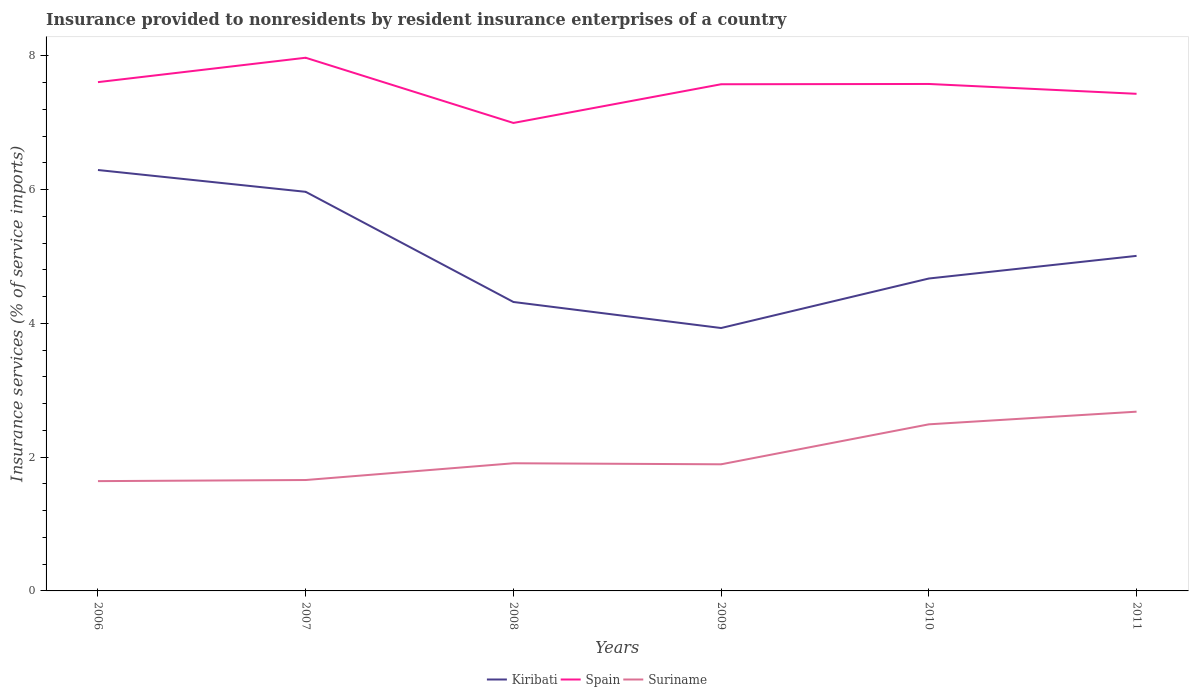Across all years, what is the maximum insurance provided to nonresidents in Spain?
Your response must be concise. 7. In which year was the insurance provided to nonresidents in Kiribati maximum?
Provide a succinct answer. 2009. What is the total insurance provided to nonresidents in Suriname in the graph?
Give a very brief answer. -0.23. What is the difference between the highest and the second highest insurance provided to nonresidents in Kiribati?
Provide a succinct answer. 2.36. What is the difference between the highest and the lowest insurance provided to nonresidents in Kiribati?
Your response must be concise. 2. Is the insurance provided to nonresidents in Kiribati strictly greater than the insurance provided to nonresidents in Spain over the years?
Make the answer very short. Yes. How many lines are there?
Offer a very short reply. 3. What is the difference between two consecutive major ticks on the Y-axis?
Make the answer very short. 2. Does the graph contain any zero values?
Ensure brevity in your answer.  No. Does the graph contain grids?
Provide a short and direct response. No. How are the legend labels stacked?
Give a very brief answer. Horizontal. What is the title of the graph?
Your response must be concise. Insurance provided to nonresidents by resident insurance enterprises of a country. What is the label or title of the Y-axis?
Make the answer very short. Insurance services (% of service imports). What is the Insurance services (% of service imports) of Kiribati in 2006?
Give a very brief answer. 6.29. What is the Insurance services (% of service imports) in Spain in 2006?
Make the answer very short. 7.61. What is the Insurance services (% of service imports) of Suriname in 2006?
Give a very brief answer. 1.64. What is the Insurance services (% of service imports) in Kiribati in 2007?
Give a very brief answer. 5.97. What is the Insurance services (% of service imports) in Spain in 2007?
Provide a succinct answer. 7.97. What is the Insurance services (% of service imports) of Suriname in 2007?
Ensure brevity in your answer.  1.66. What is the Insurance services (% of service imports) in Kiribati in 2008?
Make the answer very short. 4.32. What is the Insurance services (% of service imports) of Spain in 2008?
Provide a short and direct response. 7. What is the Insurance services (% of service imports) of Suriname in 2008?
Keep it short and to the point. 1.91. What is the Insurance services (% of service imports) of Kiribati in 2009?
Your answer should be very brief. 3.93. What is the Insurance services (% of service imports) of Spain in 2009?
Your answer should be very brief. 7.57. What is the Insurance services (% of service imports) in Suriname in 2009?
Your answer should be very brief. 1.89. What is the Insurance services (% of service imports) in Kiribati in 2010?
Offer a very short reply. 4.67. What is the Insurance services (% of service imports) in Spain in 2010?
Your answer should be compact. 7.58. What is the Insurance services (% of service imports) in Suriname in 2010?
Keep it short and to the point. 2.49. What is the Insurance services (% of service imports) of Kiribati in 2011?
Offer a very short reply. 5.01. What is the Insurance services (% of service imports) of Spain in 2011?
Make the answer very short. 7.43. What is the Insurance services (% of service imports) in Suriname in 2011?
Provide a succinct answer. 2.68. Across all years, what is the maximum Insurance services (% of service imports) of Kiribati?
Keep it short and to the point. 6.29. Across all years, what is the maximum Insurance services (% of service imports) in Spain?
Provide a short and direct response. 7.97. Across all years, what is the maximum Insurance services (% of service imports) of Suriname?
Your response must be concise. 2.68. Across all years, what is the minimum Insurance services (% of service imports) in Kiribati?
Provide a short and direct response. 3.93. Across all years, what is the minimum Insurance services (% of service imports) of Spain?
Your answer should be very brief. 7. Across all years, what is the minimum Insurance services (% of service imports) in Suriname?
Offer a terse response. 1.64. What is the total Insurance services (% of service imports) of Kiribati in the graph?
Provide a succinct answer. 30.19. What is the total Insurance services (% of service imports) of Spain in the graph?
Your answer should be very brief. 45.15. What is the total Insurance services (% of service imports) of Suriname in the graph?
Your answer should be compact. 12.27. What is the difference between the Insurance services (% of service imports) in Kiribati in 2006 and that in 2007?
Provide a short and direct response. 0.33. What is the difference between the Insurance services (% of service imports) in Spain in 2006 and that in 2007?
Provide a short and direct response. -0.36. What is the difference between the Insurance services (% of service imports) of Suriname in 2006 and that in 2007?
Your answer should be very brief. -0.02. What is the difference between the Insurance services (% of service imports) of Kiribati in 2006 and that in 2008?
Your answer should be very brief. 1.97. What is the difference between the Insurance services (% of service imports) of Spain in 2006 and that in 2008?
Offer a very short reply. 0.61. What is the difference between the Insurance services (% of service imports) in Suriname in 2006 and that in 2008?
Keep it short and to the point. -0.27. What is the difference between the Insurance services (% of service imports) of Kiribati in 2006 and that in 2009?
Offer a very short reply. 2.36. What is the difference between the Insurance services (% of service imports) in Spain in 2006 and that in 2009?
Keep it short and to the point. 0.03. What is the difference between the Insurance services (% of service imports) of Suriname in 2006 and that in 2009?
Make the answer very short. -0.25. What is the difference between the Insurance services (% of service imports) in Kiribati in 2006 and that in 2010?
Offer a terse response. 1.62. What is the difference between the Insurance services (% of service imports) of Spain in 2006 and that in 2010?
Offer a very short reply. 0.03. What is the difference between the Insurance services (% of service imports) of Suriname in 2006 and that in 2010?
Make the answer very short. -0.85. What is the difference between the Insurance services (% of service imports) in Kiribati in 2006 and that in 2011?
Your answer should be very brief. 1.28. What is the difference between the Insurance services (% of service imports) in Spain in 2006 and that in 2011?
Offer a terse response. 0.17. What is the difference between the Insurance services (% of service imports) in Suriname in 2006 and that in 2011?
Offer a very short reply. -1.04. What is the difference between the Insurance services (% of service imports) of Kiribati in 2007 and that in 2008?
Make the answer very short. 1.65. What is the difference between the Insurance services (% of service imports) of Spain in 2007 and that in 2008?
Make the answer very short. 0.97. What is the difference between the Insurance services (% of service imports) in Suriname in 2007 and that in 2008?
Your response must be concise. -0.25. What is the difference between the Insurance services (% of service imports) in Kiribati in 2007 and that in 2009?
Ensure brevity in your answer.  2.04. What is the difference between the Insurance services (% of service imports) in Spain in 2007 and that in 2009?
Give a very brief answer. 0.4. What is the difference between the Insurance services (% of service imports) of Suriname in 2007 and that in 2009?
Offer a very short reply. -0.23. What is the difference between the Insurance services (% of service imports) in Kiribati in 2007 and that in 2010?
Your answer should be very brief. 1.3. What is the difference between the Insurance services (% of service imports) in Spain in 2007 and that in 2010?
Offer a very short reply. 0.39. What is the difference between the Insurance services (% of service imports) of Suriname in 2007 and that in 2010?
Your answer should be compact. -0.83. What is the difference between the Insurance services (% of service imports) of Kiribati in 2007 and that in 2011?
Your answer should be very brief. 0.96. What is the difference between the Insurance services (% of service imports) of Spain in 2007 and that in 2011?
Offer a terse response. 0.54. What is the difference between the Insurance services (% of service imports) of Suriname in 2007 and that in 2011?
Your answer should be compact. -1.02. What is the difference between the Insurance services (% of service imports) in Kiribati in 2008 and that in 2009?
Provide a succinct answer. 0.39. What is the difference between the Insurance services (% of service imports) in Spain in 2008 and that in 2009?
Your answer should be very brief. -0.58. What is the difference between the Insurance services (% of service imports) in Suriname in 2008 and that in 2009?
Your answer should be very brief. 0.02. What is the difference between the Insurance services (% of service imports) of Kiribati in 2008 and that in 2010?
Offer a very short reply. -0.35. What is the difference between the Insurance services (% of service imports) of Spain in 2008 and that in 2010?
Your answer should be compact. -0.58. What is the difference between the Insurance services (% of service imports) in Suriname in 2008 and that in 2010?
Keep it short and to the point. -0.58. What is the difference between the Insurance services (% of service imports) of Kiribati in 2008 and that in 2011?
Your answer should be very brief. -0.69. What is the difference between the Insurance services (% of service imports) of Spain in 2008 and that in 2011?
Offer a very short reply. -0.44. What is the difference between the Insurance services (% of service imports) of Suriname in 2008 and that in 2011?
Keep it short and to the point. -0.77. What is the difference between the Insurance services (% of service imports) in Kiribati in 2009 and that in 2010?
Your answer should be very brief. -0.74. What is the difference between the Insurance services (% of service imports) in Spain in 2009 and that in 2010?
Ensure brevity in your answer.  -0. What is the difference between the Insurance services (% of service imports) of Suriname in 2009 and that in 2010?
Keep it short and to the point. -0.6. What is the difference between the Insurance services (% of service imports) of Kiribati in 2009 and that in 2011?
Offer a very short reply. -1.08. What is the difference between the Insurance services (% of service imports) in Spain in 2009 and that in 2011?
Your answer should be compact. 0.14. What is the difference between the Insurance services (% of service imports) of Suriname in 2009 and that in 2011?
Your answer should be very brief. -0.79. What is the difference between the Insurance services (% of service imports) of Kiribati in 2010 and that in 2011?
Offer a terse response. -0.34. What is the difference between the Insurance services (% of service imports) of Spain in 2010 and that in 2011?
Make the answer very short. 0.15. What is the difference between the Insurance services (% of service imports) in Suriname in 2010 and that in 2011?
Offer a very short reply. -0.19. What is the difference between the Insurance services (% of service imports) of Kiribati in 2006 and the Insurance services (% of service imports) of Spain in 2007?
Your response must be concise. -1.68. What is the difference between the Insurance services (% of service imports) of Kiribati in 2006 and the Insurance services (% of service imports) of Suriname in 2007?
Keep it short and to the point. 4.63. What is the difference between the Insurance services (% of service imports) in Spain in 2006 and the Insurance services (% of service imports) in Suriname in 2007?
Offer a terse response. 5.95. What is the difference between the Insurance services (% of service imports) of Kiribati in 2006 and the Insurance services (% of service imports) of Spain in 2008?
Keep it short and to the point. -0.7. What is the difference between the Insurance services (% of service imports) in Kiribati in 2006 and the Insurance services (% of service imports) in Suriname in 2008?
Your answer should be compact. 4.38. What is the difference between the Insurance services (% of service imports) in Spain in 2006 and the Insurance services (% of service imports) in Suriname in 2008?
Offer a terse response. 5.7. What is the difference between the Insurance services (% of service imports) of Kiribati in 2006 and the Insurance services (% of service imports) of Spain in 2009?
Make the answer very short. -1.28. What is the difference between the Insurance services (% of service imports) in Kiribati in 2006 and the Insurance services (% of service imports) in Suriname in 2009?
Give a very brief answer. 4.4. What is the difference between the Insurance services (% of service imports) in Spain in 2006 and the Insurance services (% of service imports) in Suriname in 2009?
Ensure brevity in your answer.  5.71. What is the difference between the Insurance services (% of service imports) in Kiribati in 2006 and the Insurance services (% of service imports) in Spain in 2010?
Offer a terse response. -1.29. What is the difference between the Insurance services (% of service imports) in Kiribati in 2006 and the Insurance services (% of service imports) in Suriname in 2010?
Offer a terse response. 3.8. What is the difference between the Insurance services (% of service imports) in Spain in 2006 and the Insurance services (% of service imports) in Suriname in 2010?
Make the answer very short. 5.12. What is the difference between the Insurance services (% of service imports) in Kiribati in 2006 and the Insurance services (% of service imports) in Spain in 2011?
Ensure brevity in your answer.  -1.14. What is the difference between the Insurance services (% of service imports) of Kiribati in 2006 and the Insurance services (% of service imports) of Suriname in 2011?
Make the answer very short. 3.61. What is the difference between the Insurance services (% of service imports) of Spain in 2006 and the Insurance services (% of service imports) of Suriname in 2011?
Your answer should be very brief. 4.93. What is the difference between the Insurance services (% of service imports) in Kiribati in 2007 and the Insurance services (% of service imports) in Spain in 2008?
Keep it short and to the point. -1.03. What is the difference between the Insurance services (% of service imports) of Kiribati in 2007 and the Insurance services (% of service imports) of Suriname in 2008?
Offer a very short reply. 4.06. What is the difference between the Insurance services (% of service imports) in Spain in 2007 and the Insurance services (% of service imports) in Suriname in 2008?
Offer a terse response. 6.06. What is the difference between the Insurance services (% of service imports) of Kiribati in 2007 and the Insurance services (% of service imports) of Spain in 2009?
Offer a terse response. -1.61. What is the difference between the Insurance services (% of service imports) in Kiribati in 2007 and the Insurance services (% of service imports) in Suriname in 2009?
Provide a succinct answer. 4.07. What is the difference between the Insurance services (% of service imports) in Spain in 2007 and the Insurance services (% of service imports) in Suriname in 2009?
Provide a succinct answer. 6.08. What is the difference between the Insurance services (% of service imports) in Kiribati in 2007 and the Insurance services (% of service imports) in Spain in 2010?
Offer a terse response. -1.61. What is the difference between the Insurance services (% of service imports) in Kiribati in 2007 and the Insurance services (% of service imports) in Suriname in 2010?
Ensure brevity in your answer.  3.48. What is the difference between the Insurance services (% of service imports) in Spain in 2007 and the Insurance services (% of service imports) in Suriname in 2010?
Your answer should be compact. 5.48. What is the difference between the Insurance services (% of service imports) in Kiribati in 2007 and the Insurance services (% of service imports) in Spain in 2011?
Ensure brevity in your answer.  -1.47. What is the difference between the Insurance services (% of service imports) in Kiribati in 2007 and the Insurance services (% of service imports) in Suriname in 2011?
Provide a short and direct response. 3.29. What is the difference between the Insurance services (% of service imports) of Spain in 2007 and the Insurance services (% of service imports) of Suriname in 2011?
Give a very brief answer. 5.29. What is the difference between the Insurance services (% of service imports) of Kiribati in 2008 and the Insurance services (% of service imports) of Spain in 2009?
Ensure brevity in your answer.  -3.25. What is the difference between the Insurance services (% of service imports) in Kiribati in 2008 and the Insurance services (% of service imports) in Suriname in 2009?
Provide a short and direct response. 2.43. What is the difference between the Insurance services (% of service imports) in Spain in 2008 and the Insurance services (% of service imports) in Suriname in 2009?
Your response must be concise. 5.1. What is the difference between the Insurance services (% of service imports) of Kiribati in 2008 and the Insurance services (% of service imports) of Spain in 2010?
Give a very brief answer. -3.26. What is the difference between the Insurance services (% of service imports) in Kiribati in 2008 and the Insurance services (% of service imports) in Suriname in 2010?
Give a very brief answer. 1.83. What is the difference between the Insurance services (% of service imports) in Spain in 2008 and the Insurance services (% of service imports) in Suriname in 2010?
Your answer should be very brief. 4.51. What is the difference between the Insurance services (% of service imports) in Kiribati in 2008 and the Insurance services (% of service imports) in Spain in 2011?
Make the answer very short. -3.11. What is the difference between the Insurance services (% of service imports) in Kiribati in 2008 and the Insurance services (% of service imports) in Suriname in 2011?
Provide a succinct answer. 1.64. What is the difference between the Insurance services (% of service imports) of Spain in 2008 and the Insurance services (% of service imports) of Suriname in 2011?
Provide a short and direct response. 4.32. What is the difference between the Insurance services (% of service imports) of Kiribati in 2009 and the Insurance services (% of service imports) of Spain in 2010?
Give a very brief answer. -3.65. What is the difference between the Insurance services (% of service imports) in Kiribati in 2009 and the Insurance services (% of service imports) in Suriname in 2010?
Provide a succinct answer. 1.44. What is the difference between the Insurance services (% of service imports) in Spain in 2009 and the Insurance services (% of service imports) in Suriname in 2010?
Provide a succinct answer. 5.08. What is the difference between the Insurance services (% of service imports) of Kiribati in 2009 and the Insurance services (% of service imports) of Spain in 2011?
Your answer should be very brief. -3.5. What is the difference between the Insurance services (% of service imports) of Kiribati in 2009 and the Insurance services (% of service imports) of Suriname in 2011?
Provide a succinct answer. 1.25. What is the difference between the Insurance services (% of service imports) in Spain in 2009 and the Insurance services (% of service imports) in Suriname in 2011?
Provide a succinct answer. 4.89. What is the difference between the Insurance services (% of service imports) in Kiribati in 2010 and the Insurance services (% of service imports) in Spain in 2011?
Provide a short and direct response. -2.76. What is the difference between the Insurance services (% of service imports) of Kiribati in 2010 and the Insurance services (% of service imports) of Suriname in 2011?
Ensure brevity in your answer.  1.99. What is the difference between the Insurance services (% of service imports) in Spain in 2010 and the Insurance services (% of service imports) in Suriname in 2011?
Make the answer very short. 4.9. What is the average Insurance services (% of service imports) of Kiribati per year?
Provide a short and direct response. 5.03. What is the average Insurance services (% of service imports) in Spain per year?
Your response must be concise. 7.53. What is the average Insurance services (% of service imports) in Suriname per year?
Offer a very short reply. 2.04. In the year 2006, what is the difference between the Insurance services (% of service imports) in Kiribati and Insurance services (% of service imports) in Spain?
Give a very brief answer. -1.31. In the year 2006, what is the difference between the Insurance services (% of service imports) of Kiribati and Insurance services (% of service imports) of Suriname?
Your answer should be compact. 4.65. In the year 2006, what is the difference between the Insurance services (% of service imports) in Spain and Insurance services (% of service imports) in Suriname?
Your answer should be very brief. 5.96. In the year 2007, what is the difference between the Insurance services (% of service imports) of Kiribati and Insurance services (% of service imports) of Spain?
Your answer should be very brief. -2. In the year 2007, what is the difference between the Insurance services (% of service imports) in Kiribati and Insurance services (% of service imports) in Suriname?
Make the answer very short. 4.31. In the year 2007, what is the difference between the Insurance services (% of service imports) in Spain and Insurance services (% of service imports) in Suriname?
Keep it short and to the point. 6.31. In the year 2008, what is the difference between the Insurance services (% of service imports) in Kiribati and Insurance services (% of service imports) in Spain?
Make the answer very short. -2.68. In the year 2008, what is the difference between the Insurance services (% of service imports) of Kiribati and Insurance services (% of service imports) of Suriname?
Your response must be concise. 2.41. In the year 2008, what is the difference between the Insurance services (% of service imports) of Spain and Insurance services (% of service imports) of Suriname?
Provide a short and direct response. 5.09. In the year 2009, what is the difference between the Insurance services (% of service imports) in Kiribati and Insurance services (% of service imports) in Spain?
Your response must be concise. -3.64. In the year 2009, what is the difference between the Insurance services (% of service imports) of Kiribati and Insurance services (% of service imports) of Suriname?
Keep it short and to the point. 2.04. In the year 2009, what is the difference between the Insurance services (% of service imports) of Spain and Insurance services (% of service imports) of Suriname?
Your answer should be compact. 5.68. In the year 2010, what is the difference between the Insurance services (% of service imports) of Kiribati and Insurance services (% of service imports) of Spain?
Ensure brevity in your answer.  -2.91. In the year 2010, what is the difference between the Insurance services (% of service imports) of Kiribati and Insurance services (% of service imports) of Suriname?
Ensure brevity in your answer.  2.18. In the year 2010, what is the difference between the Insurance services (% of service imports) of Spain and Insurance services (% of service imports) of Suriname?
Your response must be concise. 5.09. In the year 2011, what is the difference between the Insurance services (% of service imports) of Kiribati and Insurance services (% of service imports) of Spain?
Give a very brief answer. -2.42. In the year 2011, what is the difference between the Insurance services (% of service imports) of Kiribati and Insurance services (% of service imports) of Suriname?
Offer a very short reply. 2.33. In the year 2011, what is the difference between the Insurance services (% of service imports) of Spain and Insurance services (% of service imports) of Suriname?
Your answer should be very brief. 4.75. What is the ratio of the Insurance services (% of service imports) of Kiribati in 2006 to that in 2007?
Your response must be concise. 1.05. What is the ratio of the Insurance services (% of service imports) in Spain in 2006 to that in 2007?
Make the answer very short. 0.95. What is the ratio of the Insurance services (% of service imports) of Kiribati in 2006 to that in 2008?
Keep it short and to the point. 1.46. What is the ratio of the Insurance services (% of service imports) in Spain in 2006 to that in 2008?
Give a very brief answer. 1.09. What is the ratio of the Insurance services (% of service imports) in Suriname in 2006 to that in 2008?
Offer a very short reply. 0.86. What is the ratio of the Insurance services (% of service imports) of Kiribati in 2006 to that in 2009?
Offer a very short reply. 1.6. What is the ratio of the Insurance services (% of service imports) of Suriname in 2006 to that in 2009?
Offer a very short reply. 0.87. What is the ratio of the Insurance services (% of service imports) in Kiribati in 2006 to that in 2010?
Your answer should be very brief. 1.35. What is the ratio of the Insurance services (% of service imports) in Suriname in 2006 to that in 2010?
Make the answer very short. 0.66. What is the ratio of the Insurance services (% of service imports) in Kiribati in 2006 to that in 2011?
Make the answer very short. 1.26. What is the ratio of the Insurance services (% of service imports) of Spain in 2006 to that in 2011?
Your answer should be very brief. 1.02. What is the ratio of the Insurance services (% of service imports) of Suriname in 2006 to that in 2011?
Give a very brief answer. 0.61. What is the ratio of the Insurance services (% of service imports) of Kiribati in 2007 to that in 2008?
Offer a terse response. 1.38. What is the ratio of the Insurance services (% of service imports) in Spain in 2007 to that in 2008?
Offer a terse response. 1.14. What is the ratio of the Insurance services (% of service imports) in Suriname in 2007 to that in 2008?
Your answer should be compact. 0.87. What is the ratio of the Insurance services (% of service imports) of Kiribati in 2007 to that in 2009?
Provide a succinct answer. 1.52. What is the ratio of the Insurance services (% of service imports) of Spain in 2007 to that in 2009?
Provide a succinct answer. 1.05. What is the ratio of the Insurance services (% of service imports) of Suriname in 2007 to that in 2009?
Your answer should be compact. 0.88. What is the ratio of the Insurance services (% of service imports) of Kiribati in 2007 to that in 2010?
Keep it short and to the point. 1.28. What is the ratio of the Insurance services (% of service imports) of Spain in 2007 to that in 2010?
Your answer should be compact. 1.05. What is the ratio of the Insurance services (% of service imports) in Suriname in 2007 to that in 2010?
Offer a terse response. 0.67. What is the ratio of the Insurance services (% of service imports) of Kiribati in 2007 to that in 2011?
Keep it short and to the point. 1.19. What is the ratio of the Insurance services (% of service imports) of Spain in 2007 to that in 2011?
Give a very brief answer. 1.07. What is the ratio of the Insurance services (% of service imports) of Suriname in 2007 to that in 2011?
Offer a terse response. 0.62. What is the ratio of the Insurance services (% of service imports) in Kiribati in 2008 to that in 2009?
Your response must be concise. 1.1. What is the ratio of the Insurance services (% of service imports) of Spain in 2008 to that in 2009?
Your response must be concise. 0.92. What is the ratio of the Insurance services (% of service imports) in Suriname in 2008 to that in 2009?
Your response must be concise. 1.01. What is the ratio of the Insurance services (% of service imports) in Kiribati in 2008 to that in 2010?
Offer a terse response. 0.92. What is the ratio of the Insurance services (% of service imports) of Spain in 2008 to that in 2010?
Provide a short and direct response. 0.92. What is the ratio of the Insurance services (% of service imports) in Suriname in 2008 to that in 2010?
Give a very brief answer. 0.77. What is the ratio of the Insurance services (% of service imports) in Kiribati in 2008 to that in 2011?
Give a very brief answer. 0.86. What is the ratio of the Insurance services (% of service imports) in Spain in 2008 to that in 2011?
Provide a short and direct response. 0.94. What is the ratio of the Insurance services (% of service imports) in Suriname in 2008 to that in 2011?
Offer a terse response. 0.71. What is the ratio of the Insurance services (% of service imports) in Kiribati in 2009 to that in 2010?
Keep it short and to the point. 0.84. What is the ratio of the Insurance services (% of service imports) in Spain in 2009 to that in 2010?
Keep it short and to the point. 1. What is the ratio of the Insurance services (% of service imports) in Suriname in 2009 to that in 2010?
Ensure brevity in your answer.  0.76. What is the ratio of the Insurance services (% of service imports) of Kiribati in 2009 to that in 2011?
Keep it short and to the point. 0.78. What is the ratio of the Insurance services (% of service imports) in Spain in 2009 to that in 2011?
Your answer should be very brief. 1.02. What is the ratio of the Insurance services (% of service imports) in Suriname in 2009 to that in 2011?
Give a very brief answer. 0.71. What is the ratio of the Insurance services (% of service imports) in Kiribati in 2010 to that in 2011?
Your response must be concise. 0.93. What is the ratio of the Insurance services (% of service imports) of Spain in 2010 to that in 2011?
Give a very brief answer. 1.02. What is the ratio of the Insurance services (% of service imports) of Suriname in 2010 to that in 2011?
Your answer should be compact. 0.93. What is the difference between the highest and the second highest Insurance services (% of service imports) of Kiribati?
Offer a very short reply. 0.33. What is the difference between the highest and the second highest Insurance services (% of service imports) of Spain?
Provide a short and direct response. 0.36. What is the difference between the highest and the second highest Insurance services (% of service imports) in Suriname?
Offer a very short reply. 0.19. What is the difference between the highest and the lowest Insurance services (% of service imports) in Kiribati?
Your response must be concise. 2.36. What is the difference between the highest and the lowest Insurance services (% of service imports) of Spain?
Make the answer very short. 0.97. What is the difference between the highest and the lowest Insurance services (% of service imports) in Suriname?
Ensure brevity in your answer.  1.04. 